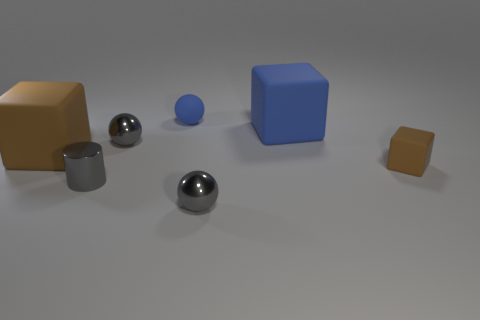Is the material of the tiny blue ball the same as the big brown thing?
Make the answer very short. Yes. There is a brown cube left of the large matte object to the right of the tiny cylinder; what size is it?
Your response must be concise. Large. Are the big object that is to the left of the blue matte cube and the big blue cube to the left of the small matte block made of the same material?
Offer a very short reply. Yes. Does the small metallic ball behind the tiny brown cube have the same color as the small shiny cylinder?
Keep it short and to the point. Yes. There is a tiny blue object; how many metallic balls are in front of it?
Keep it short and to the point. 2. Is the big blue thing made of the same material as the small gray sphere that is to the left of the blue sphere?
Your answer should be very brief. No. The blue ball that is made of the same material as the tiny block is what size?
Your answer should be very brief. Small. Are there more tiny matte things to the right of the small blue sphere than metallic spheres that are on the right side of the small brown rubber object?
Provide a short and direct response. Yes. Are there any other small metal things that have the same shape as the tiny blue object?
Your answer should be compact. Yes. Do the gray shiny sphere that is left of the blue ball and the gray cylinder have the same size?
Your answer should be very brief. Yes. 